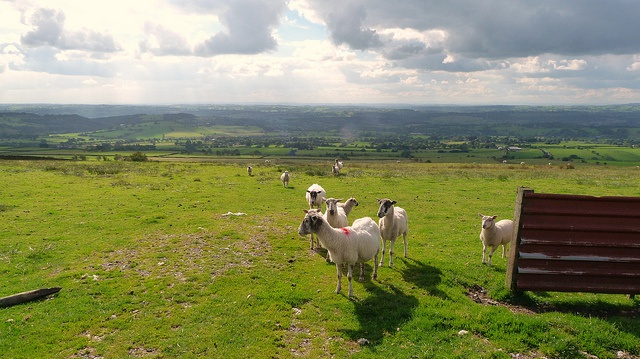Describe the objects in this image and their specific colors. I can see sheep in white, gray, and olive tones, sheep in white, gray, and tan tones, sheep in white, olive, gray, and tan tones, sheep in white, gray, and tan tones, and sheep in white, ivory, and gray tones in this image. 